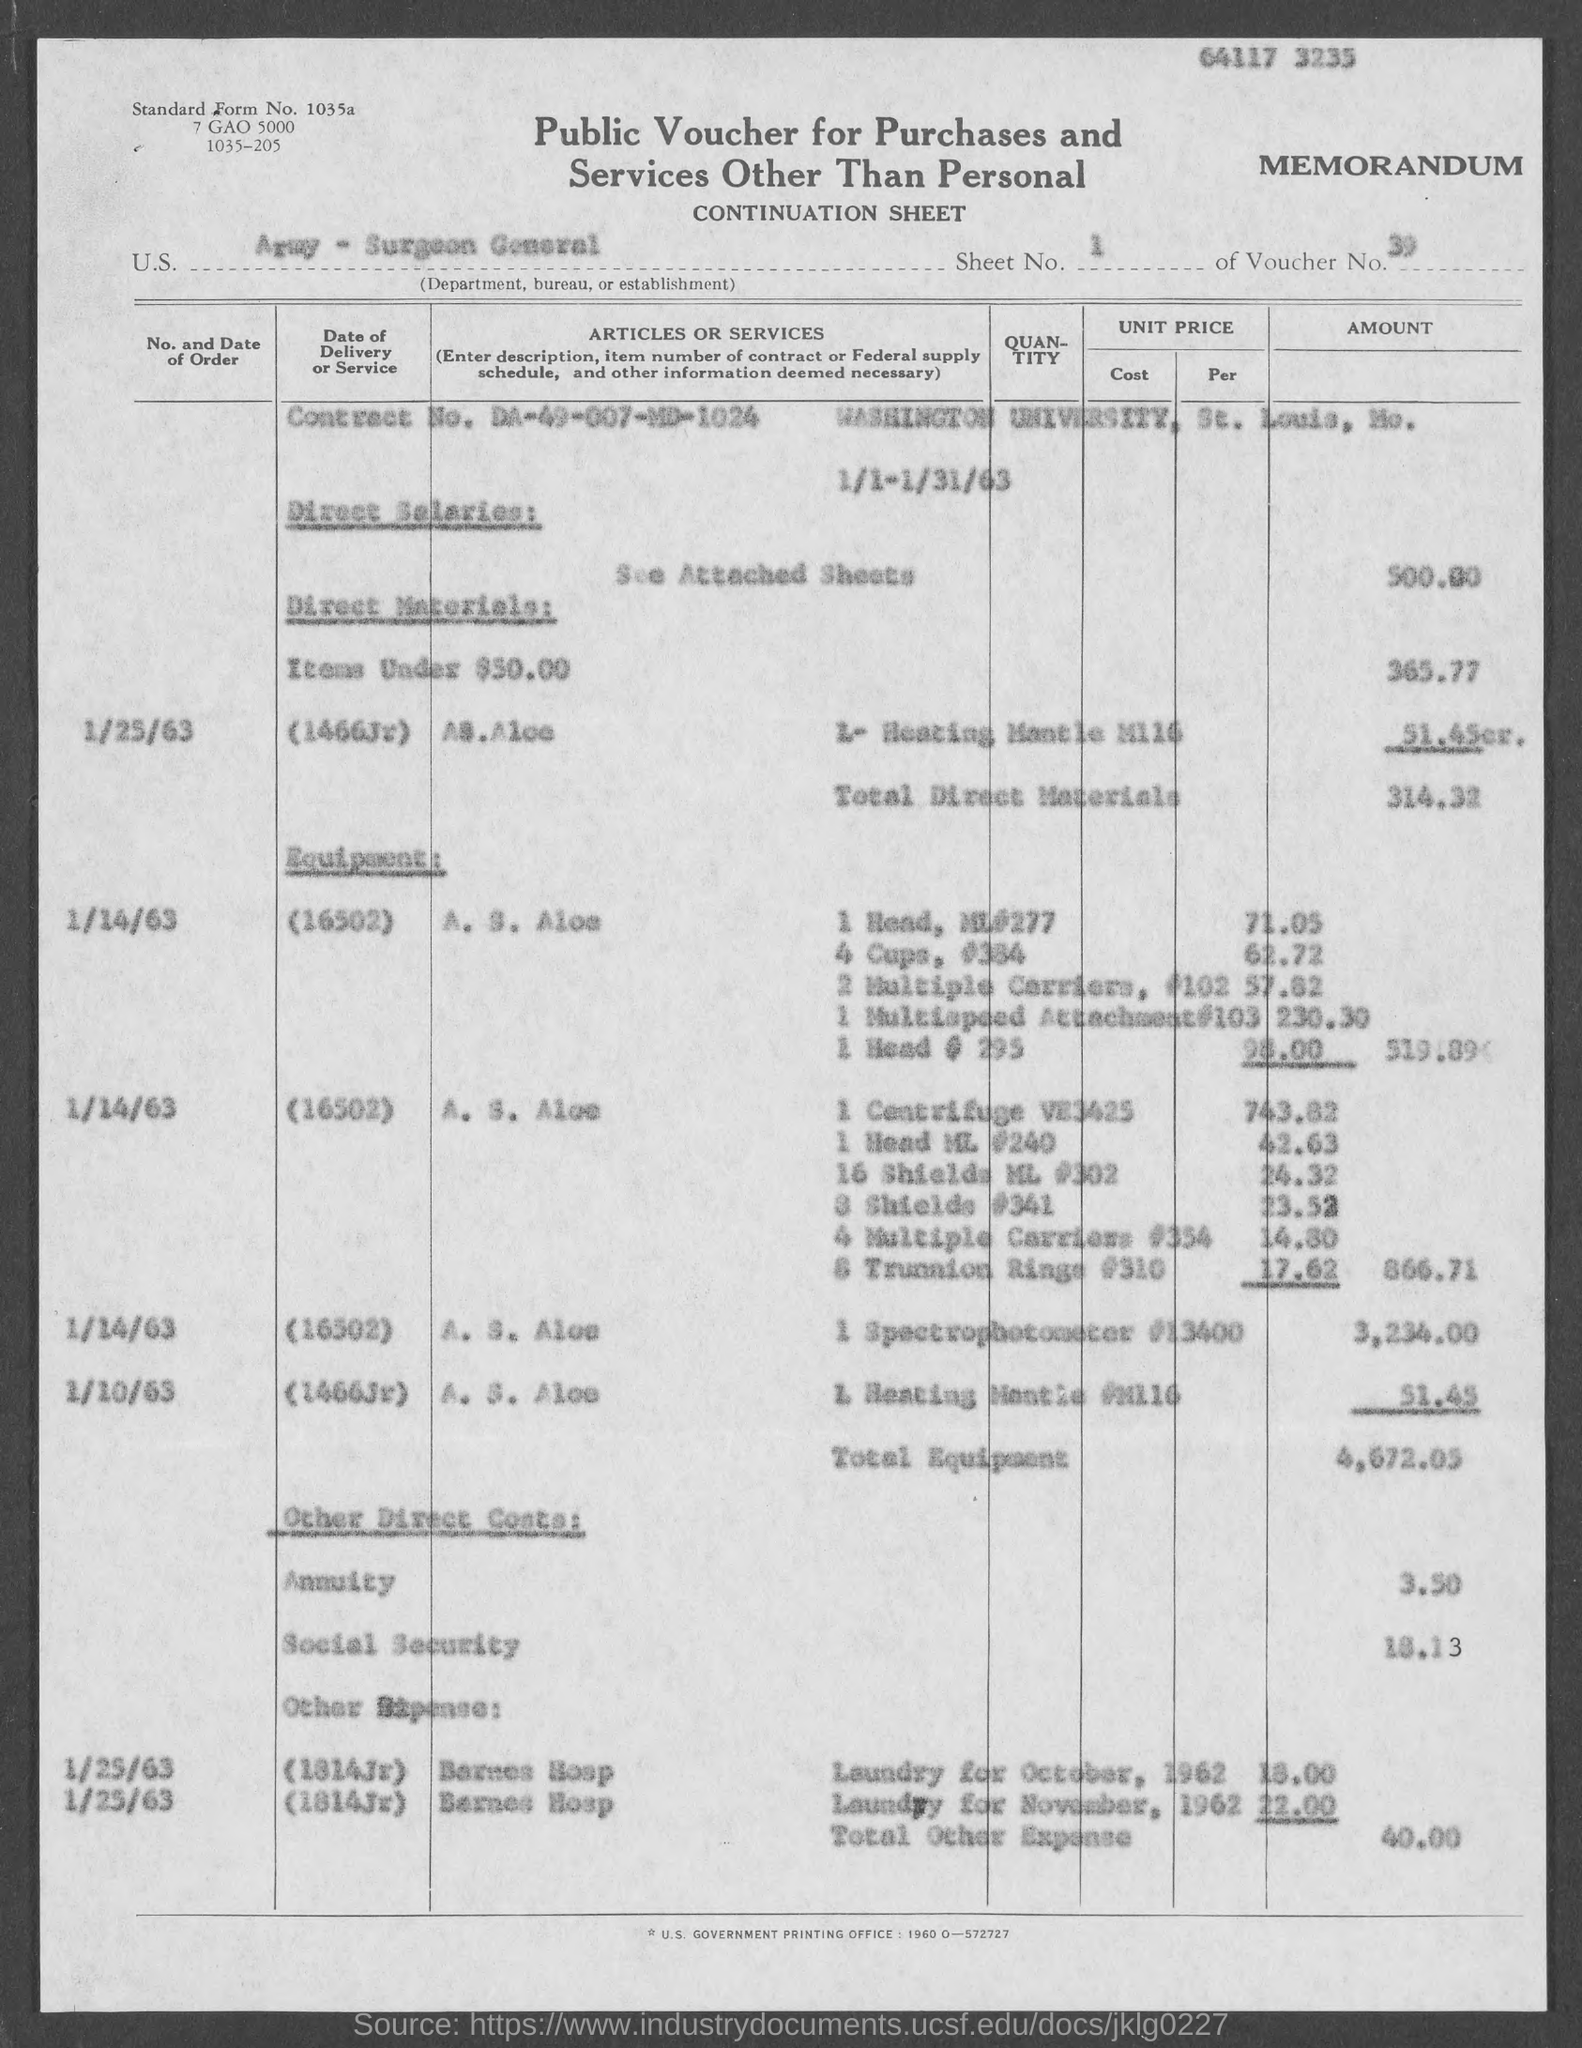Outline some significant characteristics in this image. The total equipment is 4,672.05.. Washington University is located in St. Louis, the city where it is situated. The contract number is DA-49-007-MD-1024. Total other expenses amounted to $40.00. The total direct materials amounted to 314.32... 